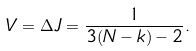Convert formula to latex. <formula><loc_0><loc_0><loc_500><loc_500>V = \Delta J = \frac { 1 } { 3 ( N - k ) - 2 } .</formula> 